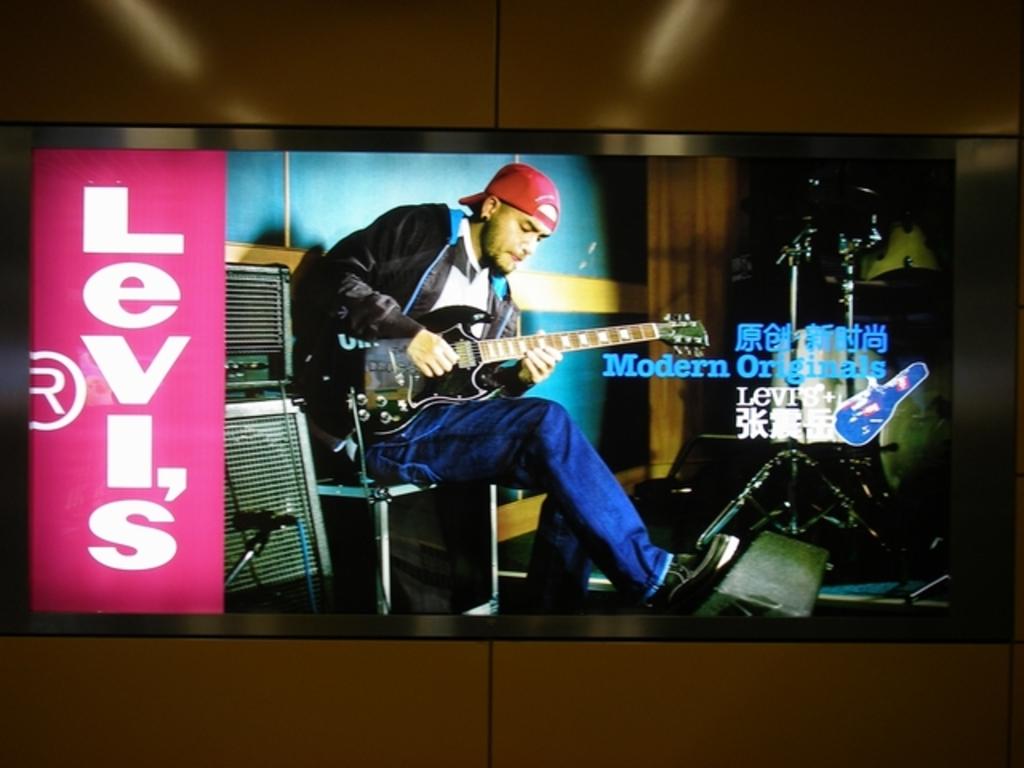What clothing brand is advertised on the screen?
Make the answer very short. Levi's. What type of originals is mentioned?
Give a very brief answer. Modern. 